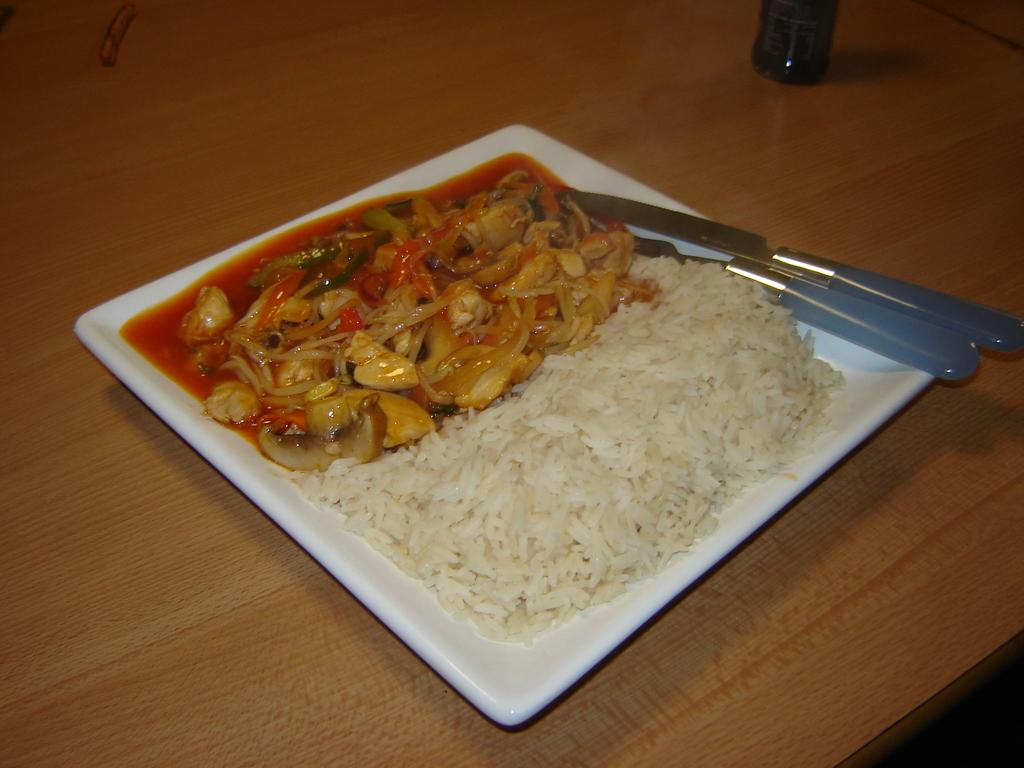What is located at the bottom of the image? There is a table at the bottom of the image. What is on the table? There is a plate containing food on the table. What utensils are present on the table? Knives are present on the table. What else can be seen on the table? There is an object placed on the table. What type of feeling can be seen on the plate in the image? There is no feeling present on the plate in the image; it contains food. 